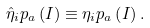Convert formula to latex. <formula><loc_0><loc_0><loc_500><loc_500>\hat { \eta } _ { i } p _ { a } \left ( I \right ) \equiv \eta _ { i } p _ { a } \left ( I \right ) .</formula> 